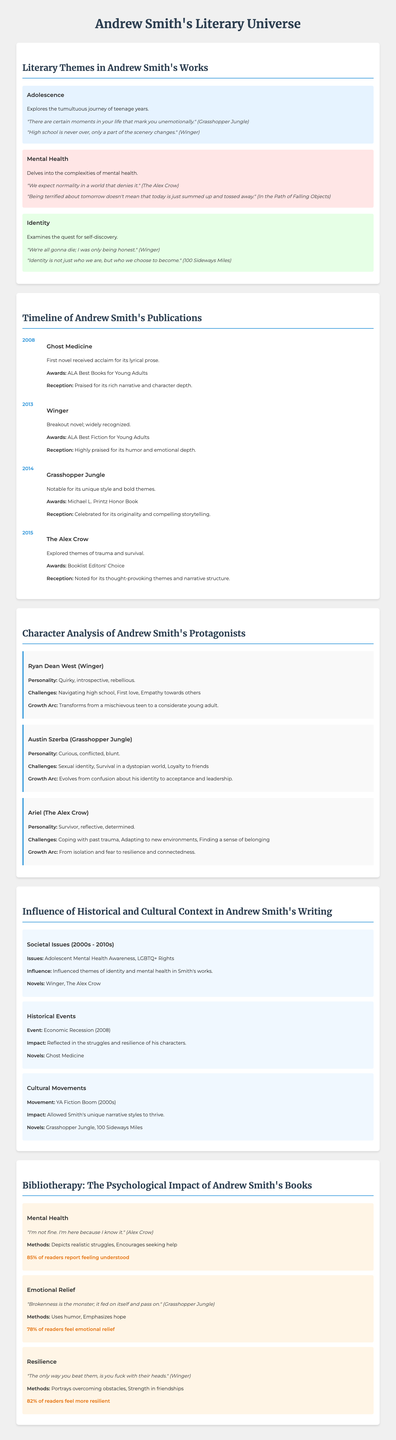what are the literary themes in Andrew Smith's works? The themes include Adolescence, Mental Health, and Identity, as highlighted in the infographic.
Answer: Adolescence, Mental Health, Identity which novel marked Andrew Smith's first publication? The document states that "Ghost Medicine" is the first novel published in 2008.
Answer: Ghost Medicine how many awards did "Grasshopper Jungle" win? The infographic notes that "Grasshopper Jungle" received the Michael L. Printz Honor Book.
Answer: 1 what character from "Winger" is analyzed in the infographic? The character analyzed is Ryan Dean West, with details about his personality and growth arc.
Answer: Ryan Dean West in what year did Andrew Smith publish "The Alex Crow"? The infographic indicates that "The Alex Crow" was published in 2015.
Answer: 2015 which thematic element emphasizes the complexities of mental health? The section on Mental Health explores the complexities of this theme in Smith's works.
Answer: Mental Health what percentage of readers feel emotional relief after reading Andrew Smith's literature? The infographic states that 78% of readers report feeling emotional relief.
Answer: 78% which historical event influenced Andrew Smith's writing according to the document? The Economic Recession (2008) is mentioned as an influential historical event in his works.
Answer: Economic Recession (2008) 